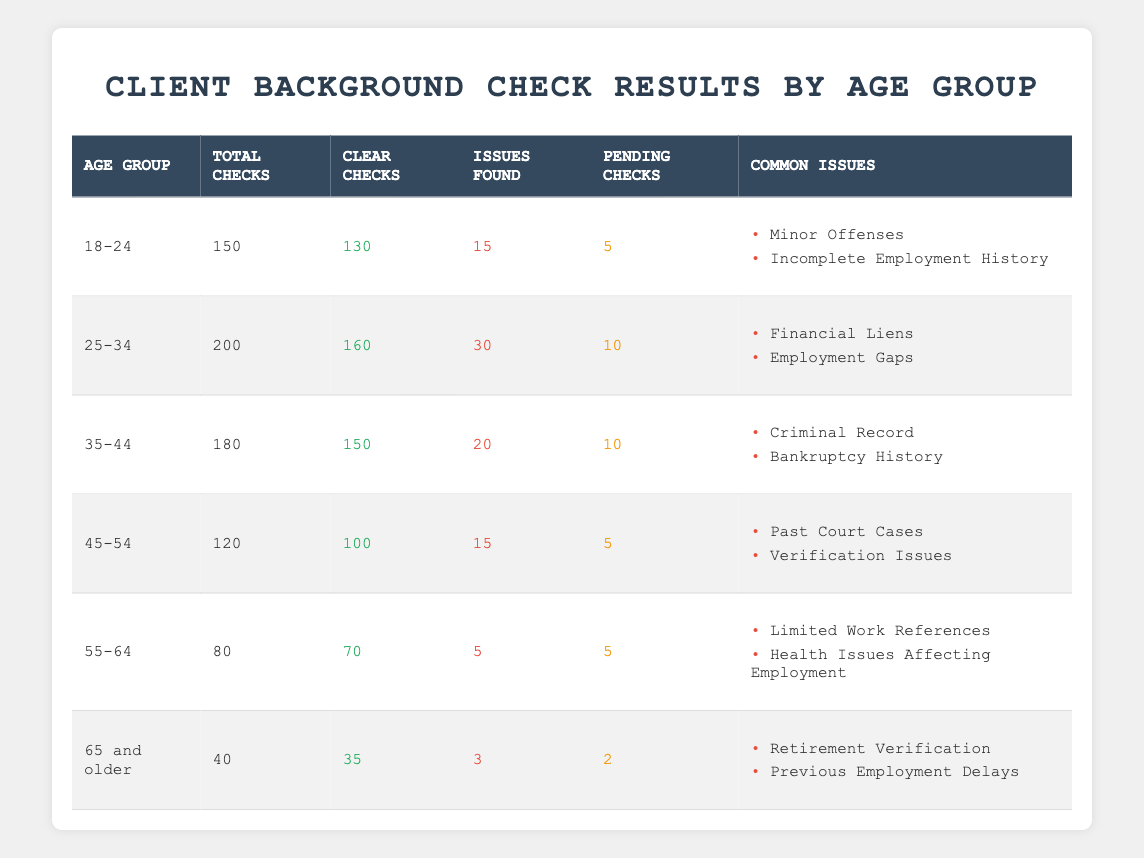What is the age group with the highest number of total checks? The table shows that the age group 25-34 has the highest number of total checks, with a total of 200 checks. This can be seen directly from the "Total Checks" column.
Answer: 25-34 How many issues were found in the age group 45-54? According to the table, there were 15 issues found in the age group 45-54, as indicated in the "Issues Found" column.
Answer: 15 What is the percentage of clear checks for the age group 35-44? To calculate the percentage of clear checks, you take the number of clear checks (150) and divide it by the total checks (180), then multiply by 100. This gives (150/180) * 100 = 83.33%.
Answer: 83.33% Is there any age group where all checks were clear? No, according to the table, all age groups show some issues found or pending checks, so there is no age group where all checks were clear.
Answer: No What is the total number of pending checks for all age groups combined? To find the total number of pending checks, sum the pending checks from each age group: 5 + 10 + 10 + 5 + 5 + 2 = 37. This requires adding the values from the "Pending Checks" column across all age groups.
Answer: 37 In which age group are the common issues related to "Criminal Record" and "Bankruptcy History"? The common issues of "Criminal Record" and "Bankruptcy History" are related to the age group 35-44 as noted in the "Common Issues" column for that age group.
Answer: 35-44 What is the combined total of checks for the age groups 18-24 and 55-64? To obtain the combined total of checks, add the total checks for age groups 18-24 (150) and 55-64 (80), which results in 150 + 80 = 230.
Answer: 230 How many age groups have issues found greater than 20? From the data, the age groups 25-34 and 35-44 have issues found greater than 20 (30 and 20 respectively), so there are 2 age groups that meet this criterion.
Answer: 2 What is the most common issue across all age groups? The most common issue across all age groups is not directly evident, but "Verification Issues" appears in age groups 45-54 and other issues vary by age. A detailed analysis across data is needed for a clear answer.
Answer: Not directly available 